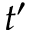<formula> <loc_0><loc_0><loc_500><loc_500>t ^ { \prime }</formula> 